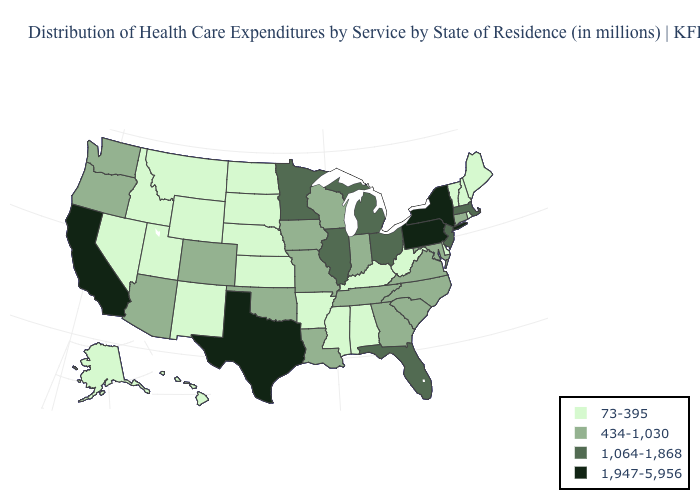Name the states that have a value in the range 434-1,030?
Be succinct. Arizona, Colorado, Connecticut, Georgia, Indiana, Iowa, Louisiana, Maryland, Missouri, North Carolina, Oklahoma, Oregon, South Carolina, Tennessee, Virginia, Washington, Wisconsin. Does the map have missing data?
Concise answer only. No. What is the value of Georgia?
Be succinct. 434-1,030. What is the lowest value in states that border Alabama?
Write a very short answer. 73-395. Which states hav the highest value in the MidWest?
Keep it brief. Illinois, Michigan, Minnesota, Ohio. Does Hawaii have the lowest value in the West?
Write a very short answer. Yes. Among the states that border Rhode Island , does Massachusetts have the highest value?
Short answer required. Yes. Name the states that have a value in the range 1,947-5,956?
Short answer required. California, New York, Pennsylvania, Texas. Among the states that border Arkansas , which have the highest value?
Concise answer only. Texas. What is the lowest value in states that border New Mexico?
Short answer required. 73-395. Does Massachusetts have the highest value in the Northeast?
Short answer required. No. Does New York have the lowest value in the Northeast?
Keep it brief. No. Which states have the lowest value in the West?
Be succinct. Alaska, Hawaii, Idaho, Montana, Nevada, New Mexico, Utah, Wyoming. 